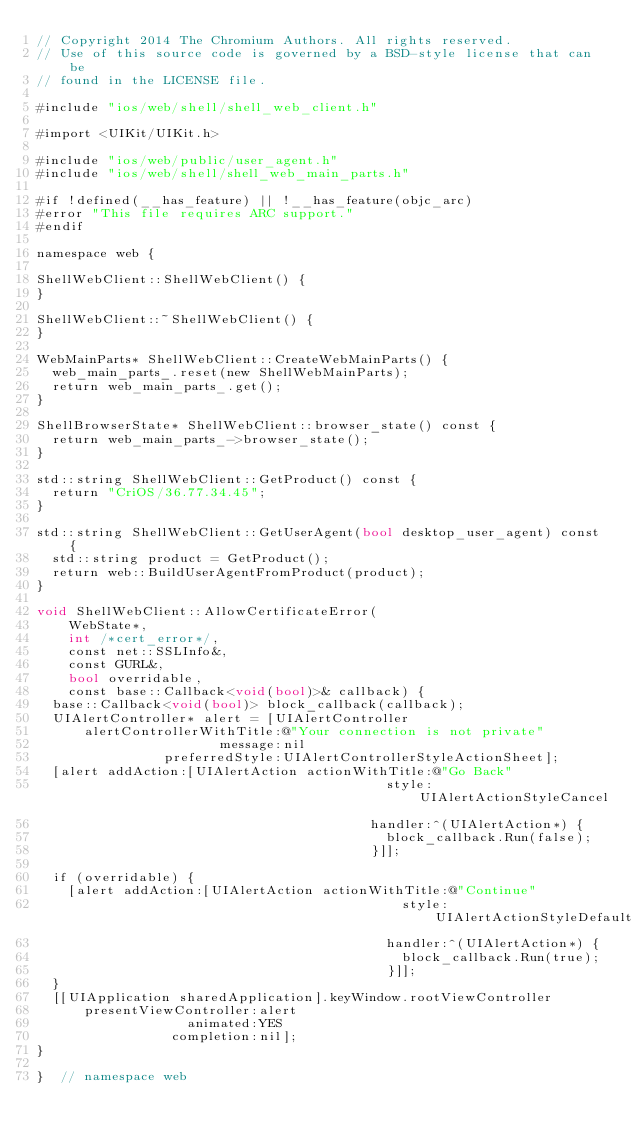Convert code to text. <code><loc_0><loc_0><loc_500><loc_500><_ObjectiveC_>// Copyright 2014 The Chromium Authors. All rights reserved.
// Use of this source code is governed by a BSD-style license that can be
// found in the LICENSE file.

#include "ios/web/shell/shell_web_client.h"

#import <UIKit/UIKit.h>

#include "ios/web/public/user_agent.h"
#include "ios/web/shell/shell_web_main_parts.h"

#if !defined(__has_feature) || !__has_feature(objc_arc)
#error "This file requires ARC support."
#endif

namespace web {

ShellWebClient::ShellWebClient() {
}

ShellWebClient::~ShellWebClient() {
}

WebMainParts* ShellWebClient::CreateWebMainParts() {
  web_main_parts_.reset(new ShellWebMainParts);
  return web_main_parts_.get();
}

ShellBrowserState* ShellWebClient::browser_state() const {
  return web_main_parts_->browser_state();
}

std::string ShellWebClient::GetProduct() const {
  return "CriOS/36.77.34.45";
}

std::string ShellWebClient::GetUserAgent(bool desktop_user_agent) const {
  std::string product = GetProduct();
  return web::BuildUserAgentFromProduct(product);
}

void ShellWebClient::AllowCertificateError(
    WebState*,
    int /*cert_error*/,
    const net::SSLInfo&,
    const GURL&,
    bool overridable,
    const base::Callback<void(bool)>& callback) {
  base::Callback<void(bool)> block_callback(callback);
  UIAlertController* alert = [UIAlertController
      alertControllerWithTitle:@"Your connection is not private"
                       message:nil
                preferredStyle:UIAlertControllerStyleActionSheet];
  [alert addAction:[UIAlertAction actionWithTitle:@"Go Back"
                                            style:UIAlertActionStyleCancel
                                          handler:^(UIAlertAction*) {
                                            block_callback.Run(false);
                                          }]];

  if (overridable) {
    [alert addAction:[UIAlertAction actionWithTitle:@"Continue"
                                              style:UIAlertActionStyleDefault
                                            handler:^(UIAlertAction*) {
                                              block_callback.Run(true);
                                            }]];
  }
  [[UIApplication sharedApplication].keyWindow.rootViewController
      presentViewController:alert
                   animated:YES
                 completion:nil];
}

}  // namespace web
</code> 